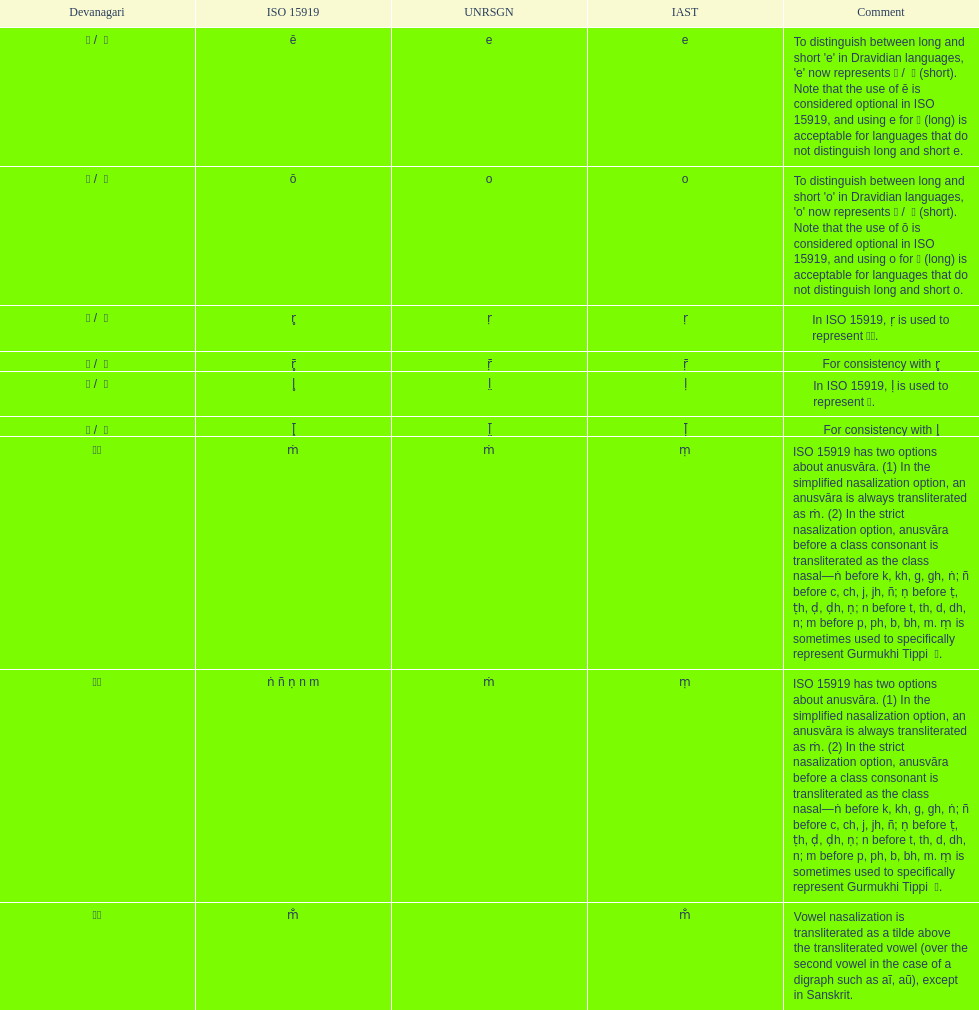What iast is listed before the o? E. 